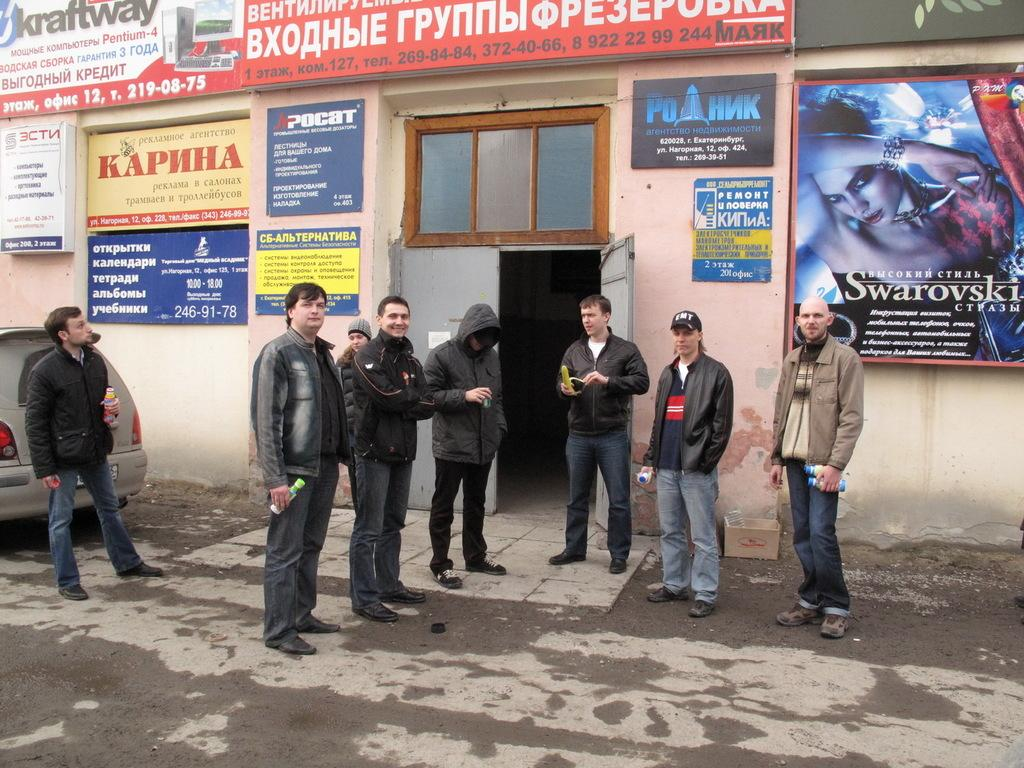What is the main feature of the image? There is a road in the image. Are there any people in the image? Yes, there are people standing in the image. What can be seen on the left side of the image? There is a car on the left side of the image. What is on the wall in the image? There are posters on a wall in the image. What is located in the middle of the image? There is a door in the middle of the image. How many chairs are visible in the image? There are no chairs visible in the image. Who is the expert standing in the image? There is no expert mentioned or visible in the image. 